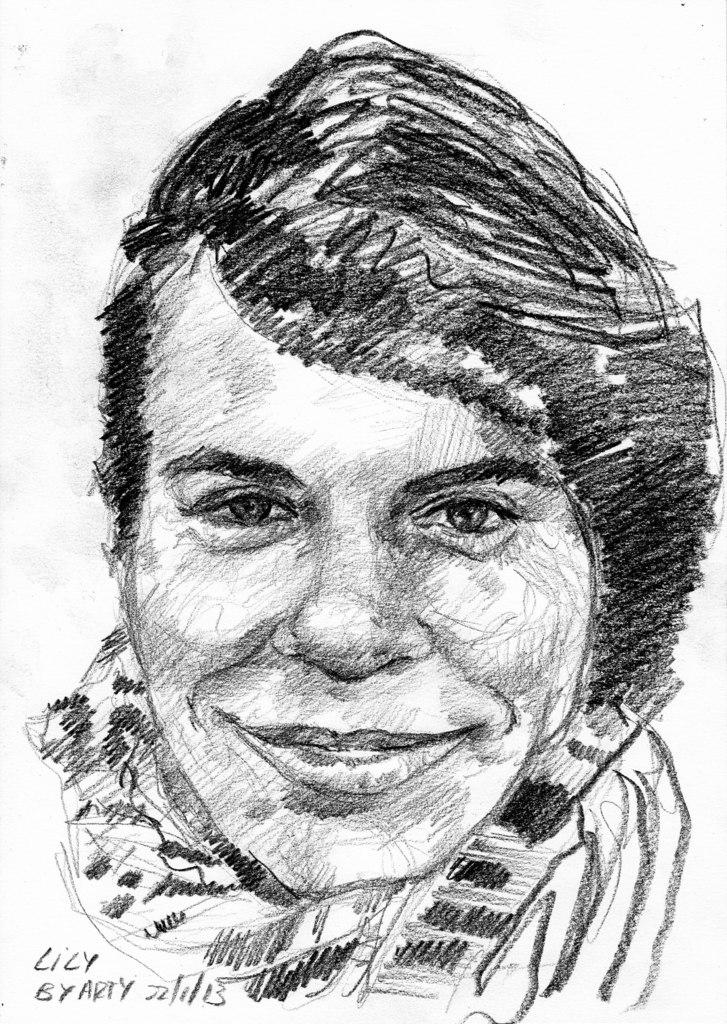What is depicted in the image? There is a drawing of a person in the image. Is there any text present in the image? Yes, there is some text in the left bottom corner of the image. How many eggs are visible in the image? There are no eggs present in the image. What type of bird can be seen in the image? There is no bird present in the image. 